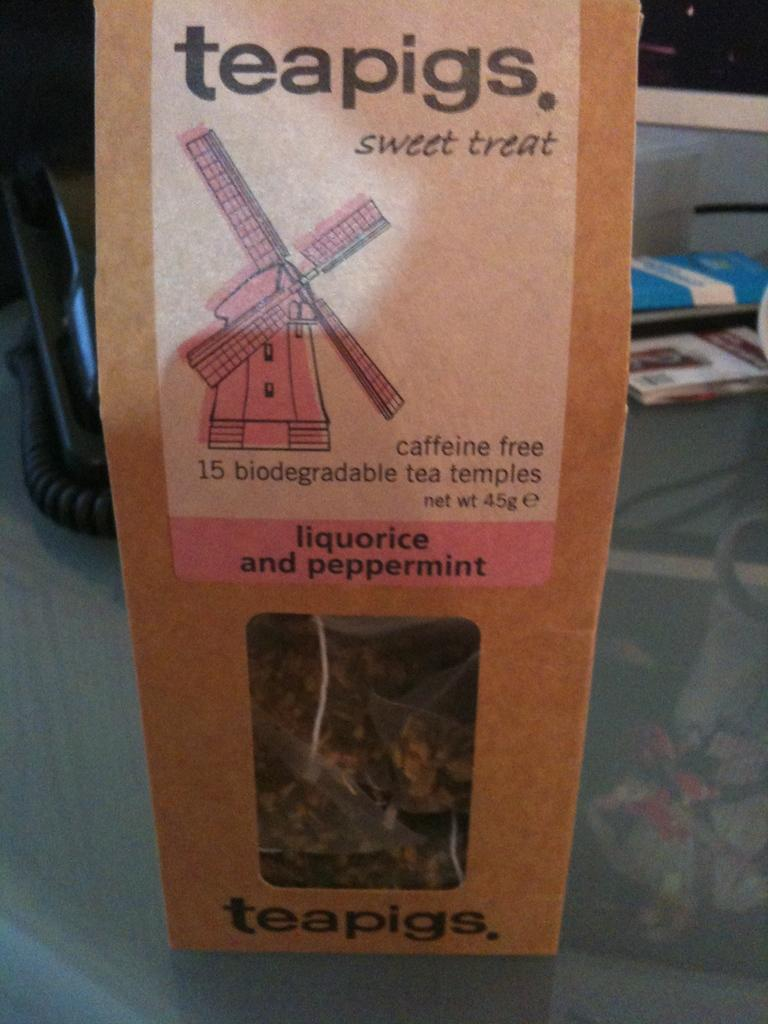<image>
Present a compact description of the photo's key features. A bag of liquorice and peppermint that is caffeine free 